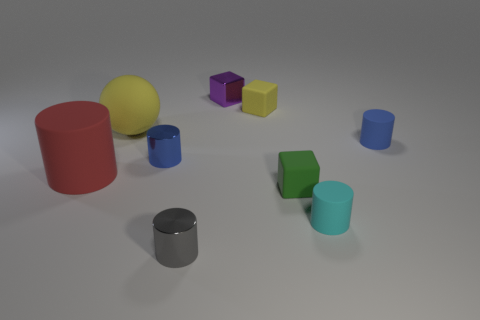How is the lighting in this scene? The lighting in the scene is soft and diffused, coming from a source that appears to be above and slightly to the right. There are subtle shadows cast by the objects, indicating the light source is not directly overhead but is still providing ample illumination to all objects. 